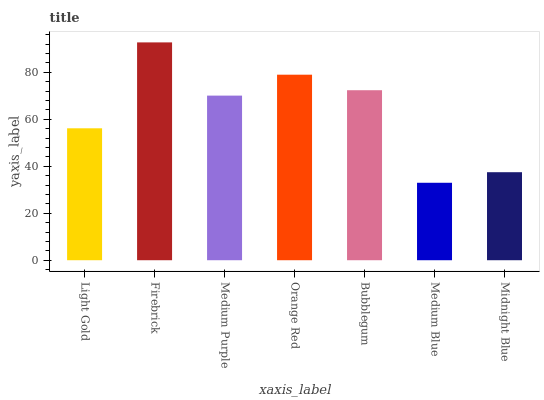Is Medium Blue the minimum?
Answer yes or no. Yes. Is Firebrick the maximum?
Answer yes or no. Yes. Is Medium Purple the minimum?
Answer yes or no. No. Is Medium Purple the maximum?
Answer yes or no. No. Is Firebrick greater than Medium Purple?
Answer yes or no. Yes. Is Medium Purple less than Firebrick?
Answer yes or no. Yes. Is Medium Purple greater than Firebrick?
Answer yes or no. No. Is Firebrick less than Medium Purple?
Answer yes or no. No. Is Medium Purple the high median?
Answer yes or no. Yes. Is Medium Purple the low median?
Answer yes or no. Yes. Is Firebrick the high median?
Answer yes or no. No. Is Orange Red the low median?
Answer yes or no. No. 